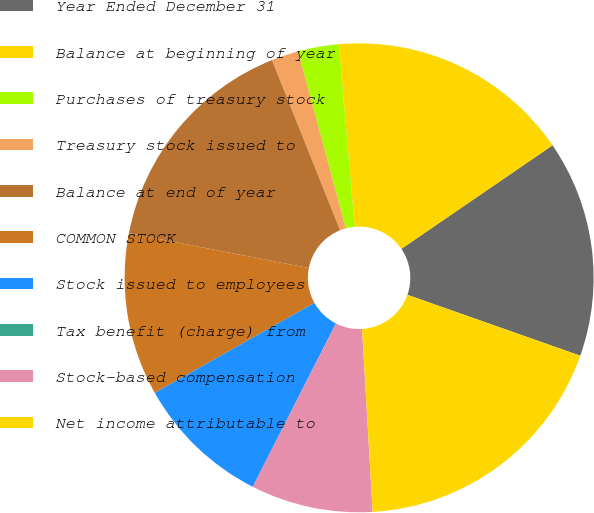<chart> <loc_0><loc_0><loc_500><loc_500><pie_chart><fcel>Year Ended December 31<fcel>Balance at beginning of year<fcel>Purchases of treasury stock<fcel>Treasury stock issued to<fcel>Balance at end of year<fcel>COMMON STOCK<fcel>Stock issued to employees<fcel>Tax benefit (charge) from<fcel>Stock-based compensation<fcel>Net income attributable to<nl><fcel>14.95%<fcel>16.82%<fcel>2.81%<fcel>1.87%<fcel>15.89%<fcel>11.21%<fcel>9.35%<fcel>0.0%<fcel>8.41%<fcel>18.69%<nl></chart> 